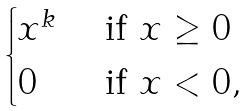Convert formula to latex. <formula><loc_0><loc_0><loc_500><loc_500>\begin{cases} x ^ { k } & \text { if } x \geq 0 \\ 0 & \text { if } x < 0 , \end{cases}</formula> 